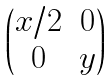Convert formula to latex. <formula><loc_0><loc_0><loc_500><loc_500>\begin{pmatrix} x / 2 & 0 \\ 0 & y \end{pmatrix}</formula> 